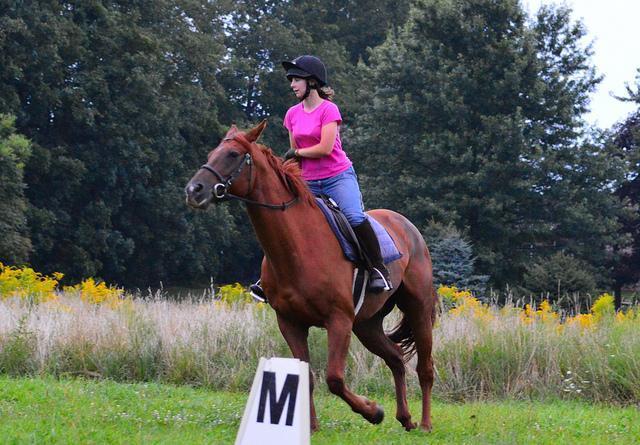How many people are on a motorcycle in the image?
Give a very brief answer. 0. 